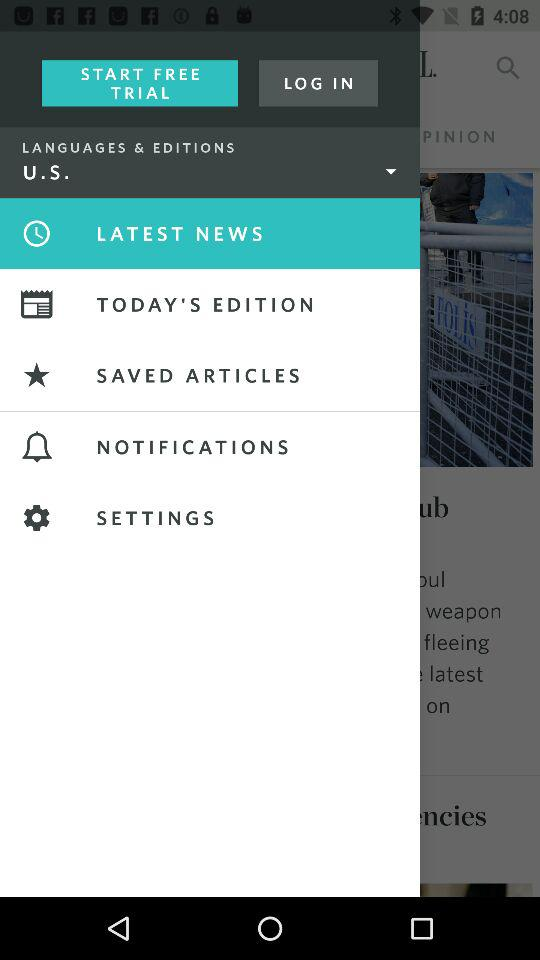Which item has been selected in the menu? The selected item is "LATEST NEWS". 